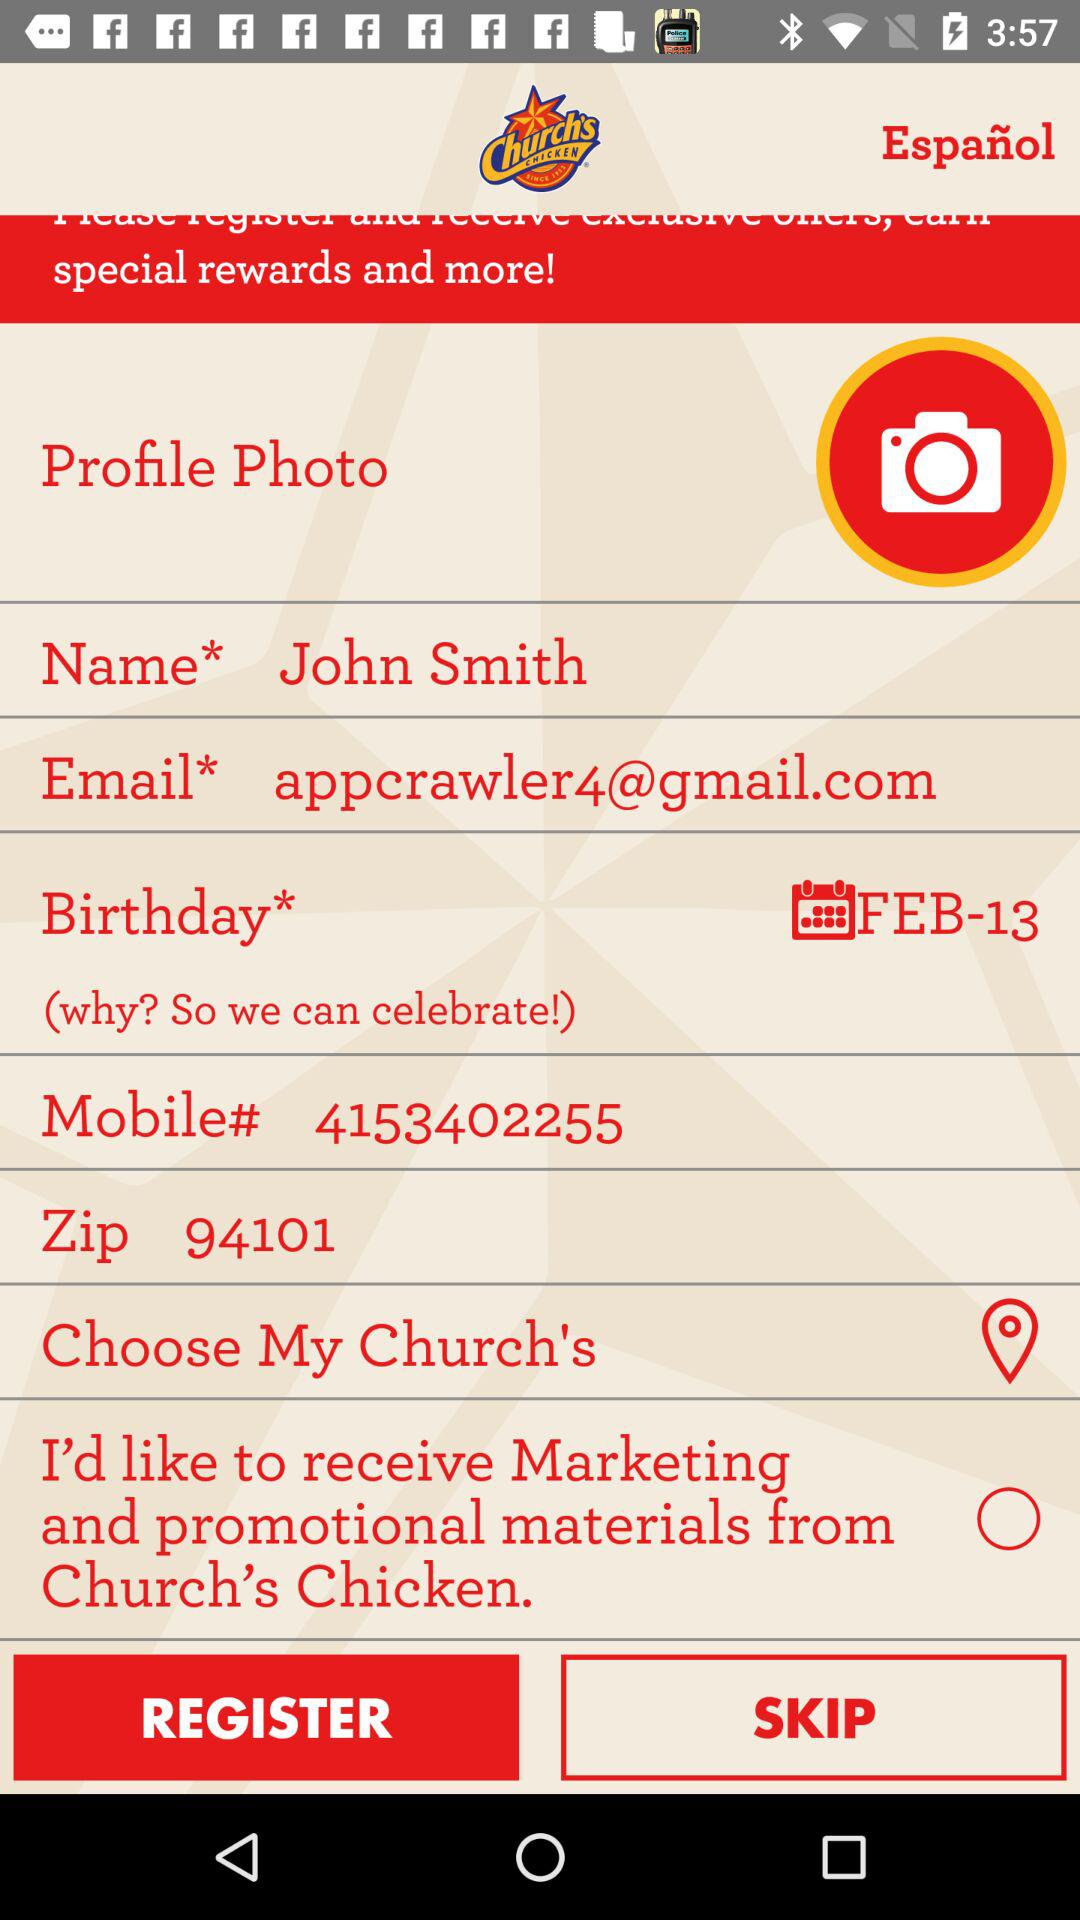What is the email address? The email address is appcrawler4@gmail.com. 